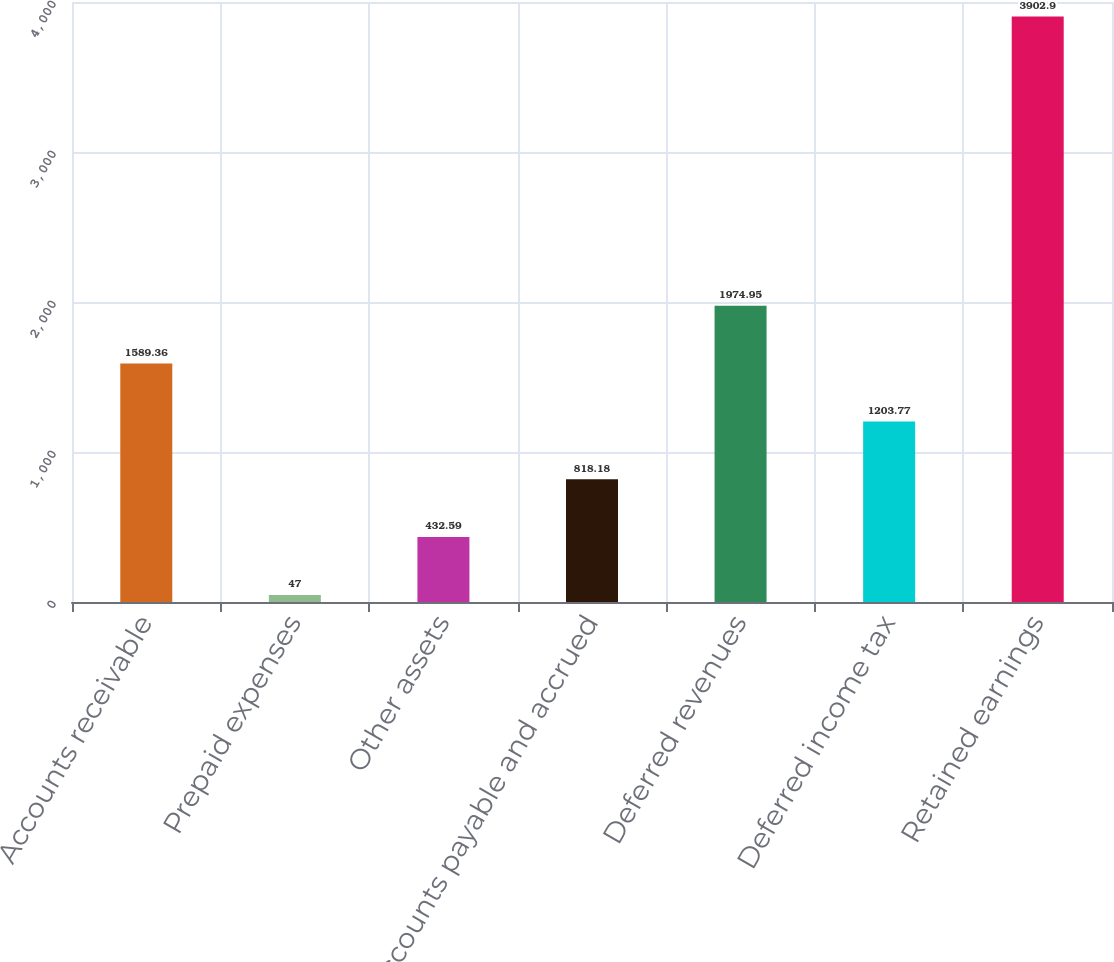Convert chart. <chart><loc_0><loc_0><loc_500><loc_500><bar_chart><fcel>Accounts receivable<fcel>Prepaid expenses<fcel>Other assets<fcel>Accounts payable and accrued<fcel>Deferred revenues<fcel>Deferred income tax<fcel>Retained earnings<nl><fcel>1589.36<fcel>47<fcel>432.59<fcel>818.18<fcel>1974.95<fcel>1203.77<fcel>3902.9<nl></chart> 